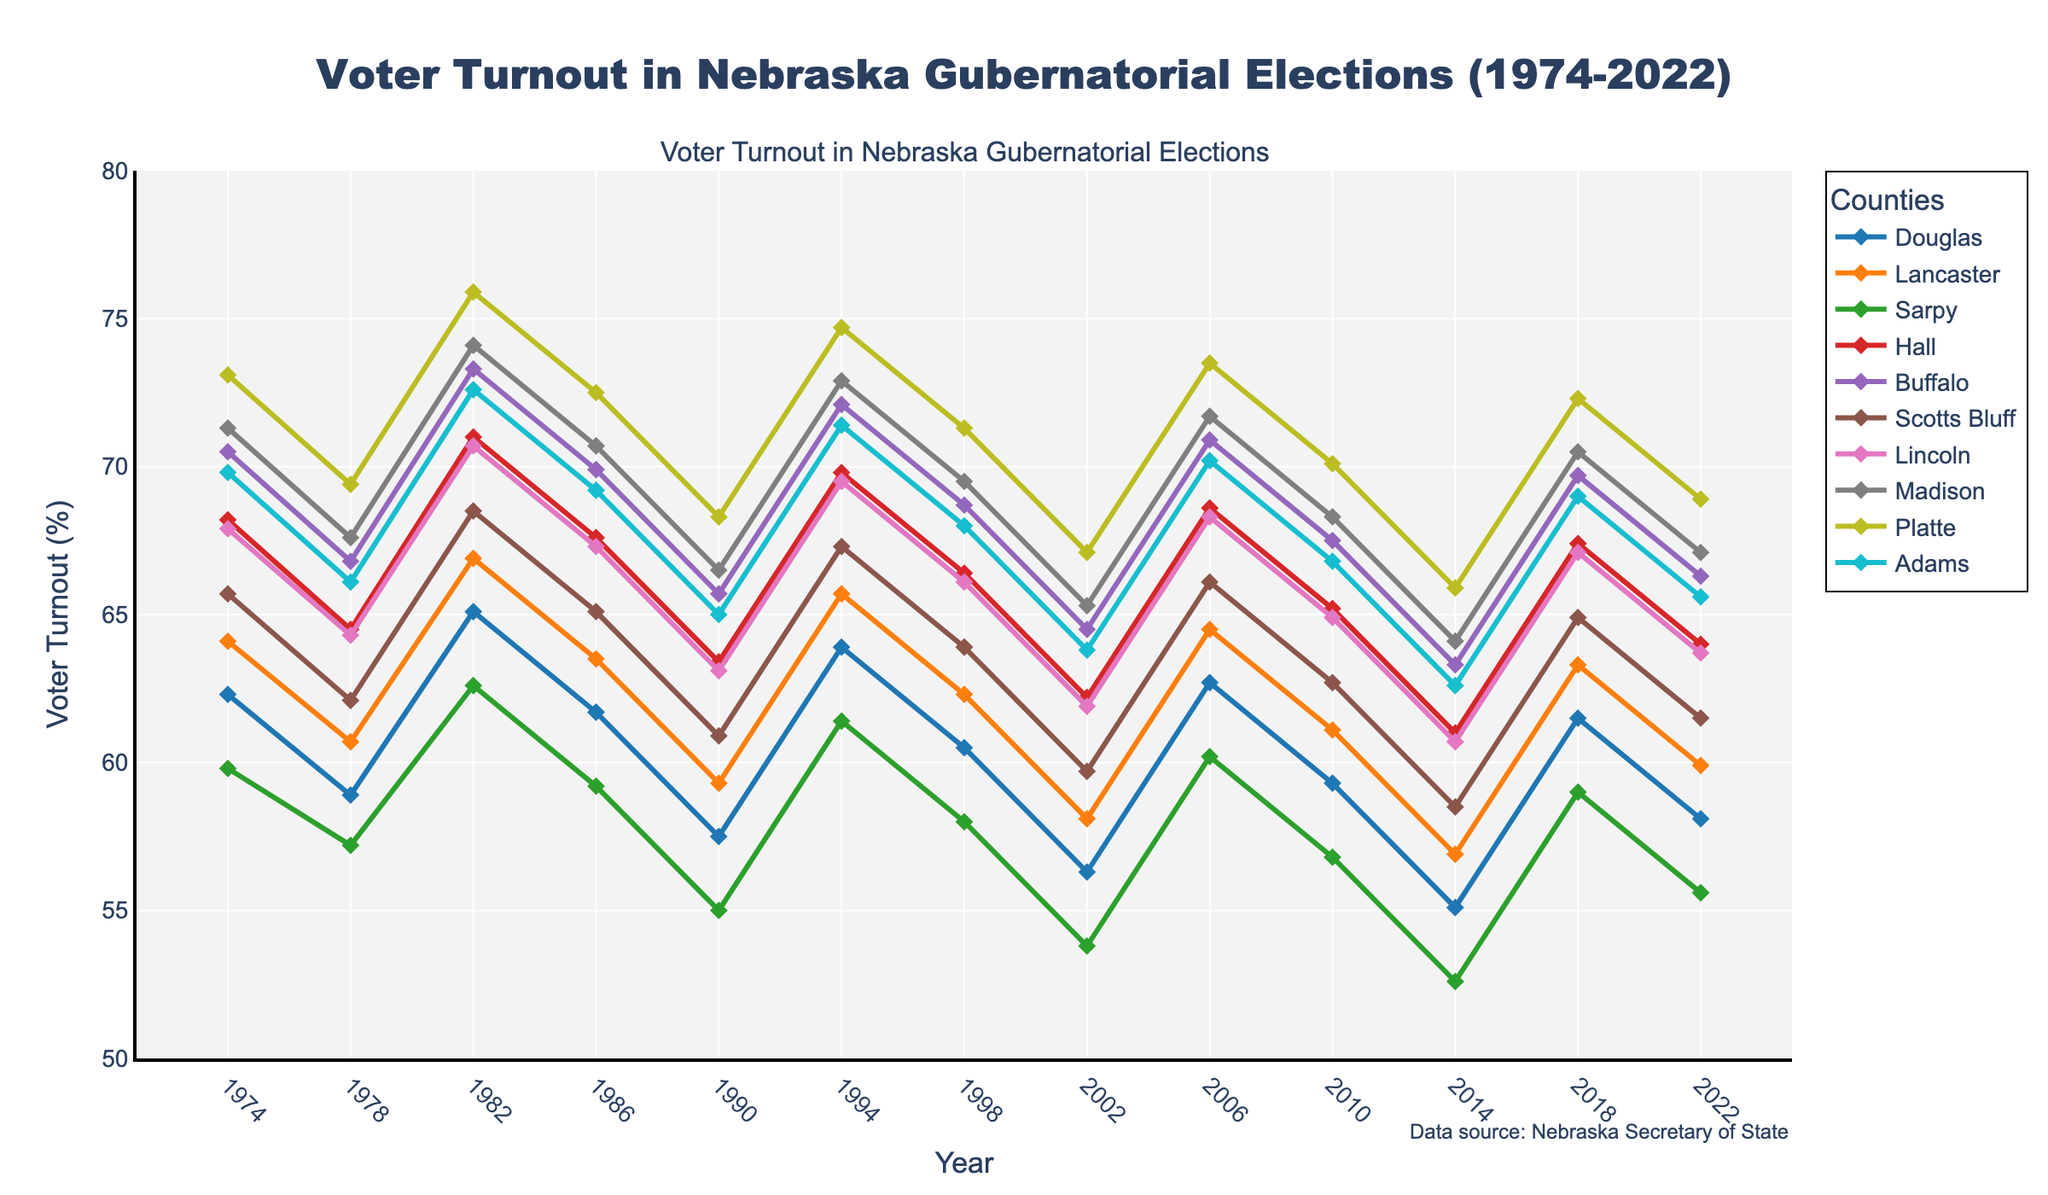What's the voter turnout trend in Douglas County from 1974 to 2022? By examining the line representing Douglas County, the voter turnout starts at 62.3% in 1974, goes through several fluctuations, and ends at 58.1% in 2022.
Answer: Decreased Which county had the highest voter turnout in 1982? The line chart shows that Platte County had the highest voter turnout in 1982, as it peaks at the highest point on the vertical axis for that year.
Answer: Platte County Comparing 2010 and 2014, did voter turnout in Hall County increase or decrease, and by how much? The voter turnout in Hall County was 65.2% in 2010 and decreased to 61.0% in 2014. The difference is calculated as 65.2% - 61.0% = 4.2%.
Answer: Decreased by 4.2% What is the average voter turnout in Buffalo County over the given years? The voter turnout values for Buffalo County from the table are: 70.5, 66.8, 73.3, 69.9, 65.7, 72.1, 68.7, 64.5, 70.9, 67.5, 63.3, 69.7, 66.3. Summing these: 889, and the count is 13. So, the average is 889/13 = 68.38%.
Answer: 68.38% Which two counties had the least variation in voter turnout rates over the 50 years? By observing the tightness of the lines and their relative flatness, Douglas and Lancaster counties exhibit the least variation, with their lines showing fewer and smaller fluctuations compared to others.
Answer: Douglas and Lancaster In which years did Lancaster County have higher voter turnout than its previous year? By examining the Lancaster County line, it shows increases in the following years relative to the previous ones: 1978 to 1982, 1986 to 1990, 2014 to 2018.
Answer: 1982, 1990, 2018 What was the voter turnout in Madison County in 1994 and how does it compare to 1998? The voter turnout in Madison County was 72.9% in 1994, and it dropped to 69.5% in 1998. The difference is 72.9% - 69.5% = 3.4%.
Answer: Decreased by 3.4% Which years show the greatest difference in voter turnout between Sarpy County and Platte County? Observing the visual spread between the Sarpy County and Platte County lines, the greatest differences are noticeable in 1982 and 1994, where Platte's turnout is significantly higher than Sarpy's.
Answer: 1982, 1994 